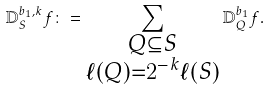<formula> <loc_0><loc_0><loc_500><loc_500>\mathbb { D } _ { S } ^ { b _ { 1 } , k } f \colon = \sum _ { \substack { Q \subseteq S \\ \ell ( Q ) = 2 ^ { - k } \ell ( S ) } } \mathbb { D } _ { Q } ^ { b _ { 1 } } f .</formula> 